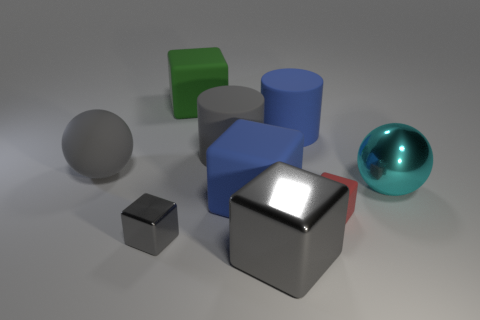Subtract all green cubes. How many cubes are left? 4 Subtract all large blue blocks. How many blocks are left? 4 Subtract all cyan blocks. Subtract all blue cylinders. How many blocks are left? 5 Add 1 large gray objects. How many objects exist? 10 Subtract all cubes. How many objects are left? 4 Add 1 big rubber spheres. How many big rubber spheres are left? 2 Add 4 big gray things. How many big gray things exist? 7 Subtract 0 red balls. How many objects are left? 9 Subtract all large green metal balls. Subtract all blue cylinders. How many objects are left? 8 